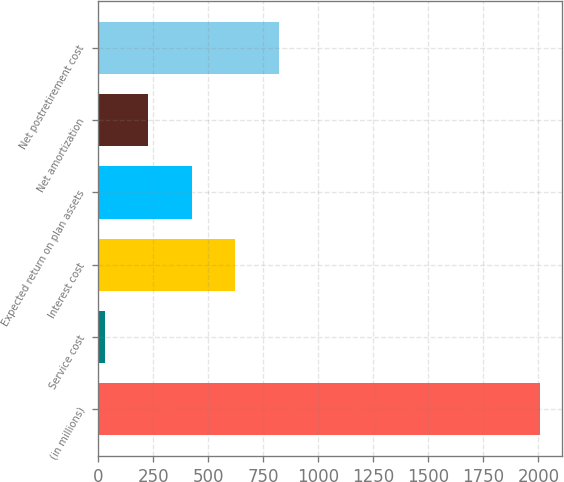Convert chart. <chart><loc_0><loc_0><loc_500><loc_500><bar_chart><fcel>(in millions)<fcel>Service cost<fcel>Interest cost<fcel>Expected return on plan assets<fcel>Net amortization<fcel>Net postretirement cost<nl><fcel>2006<fcel>30<fcel>622.8<fcel>425.2<fcel>227.6<fcel>820.4<nl></chart> 